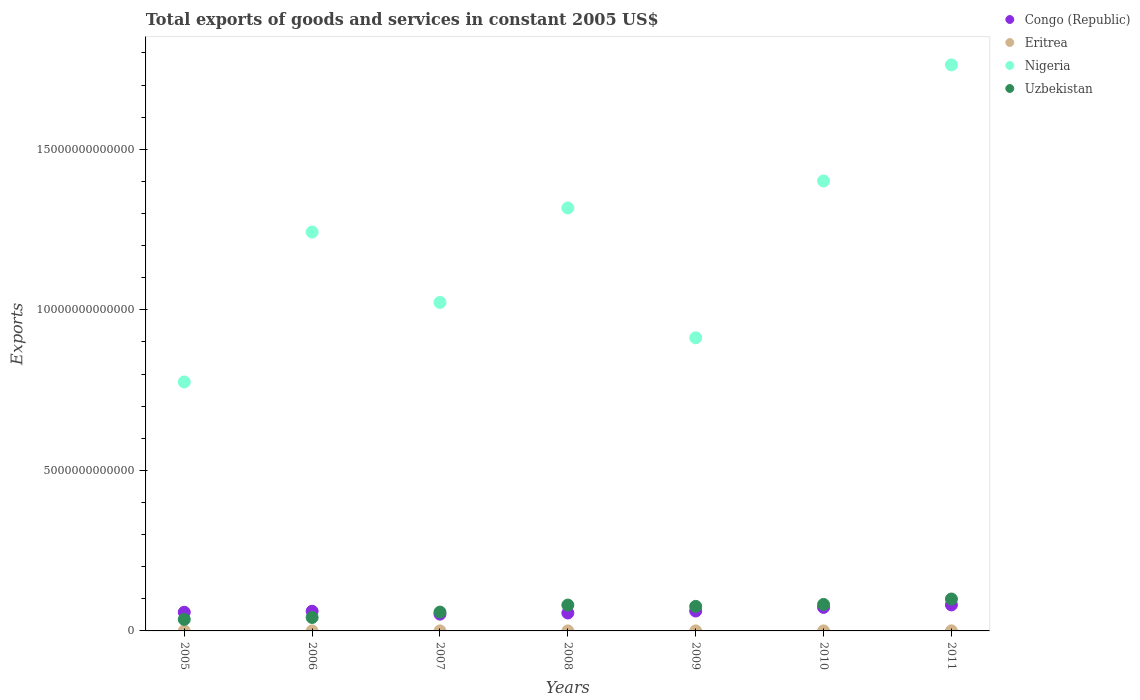How many different coloured dotlines are there?
Give a very brief answer. 4. Is the number of dotlines equal to the number of legend labels?
Provide a short and direct response. Yes. What is the total exports of goods and services in Eritrea in 2005?
Your answer should be compact. 6.78e+08. Across all years, what is the maximum total exports of goods and services in Eritrea?
Give a very brief answer. 2.84e+09. Across all years, what is the minimum total exports of goods and services in Eritrea?
Provide a short and direct response. 5.33e+08. In which year was the total exports of goods and services in Eritrea minimum?
Offer a very short reply. 2008. What is the total total exports of goods and services in Uzbekistan in the graph?
Keep it short and to the point. 4.75e+12. What is the difference between the total exports of goods and services in Congo (Republic) in 2010 and that in 2011?
Keep it short and to the point. -7.70e+1. What is the difference between the total exports of goods and services in Nigeria in 2011 and the total exports of goods and services in Congo (Republic) in 2007?
Offer a terse response. 1.71e+13. What is the average total exports of goods and services in Nigeria per year?
Keep it short and to the point. 1.20e+13. In the year 2006, what is the difference between the total exports of goods and services in Nigeria and total exports of goods and services in Uzbekistan?
Offer a terse response. 1.20e+13. What is the ratio of the total exports of goods and services in Congo (Republic) in 2005 to that in 2006?
Keep it short and to the point. 0.95. Is the total exports of goods and services in Nigeria in 2006 less than that in 2009?
Make the answer very short. No. What is the difference between the highest and the second highest total exports of goods and services in Congo (Republic)?
Provide a short and direct response. 7.70e+1. What is the difference between the highest and the lowest total exports of goods and services in Congo (Republic)?
Your answer should be compact. 2.87e+11. Is it the case that in every year, the sum of the total exports of goods and services in Nigeria and total exports of goods and services in Congo (Republic)  is greater than the sum of total exports of goods and services in Uzbekistan and total exports of goods and services in Eritrea?
Your response must be concise. Yes. Is it the case that in every year, the sum of the total exports of goods and services in Eritrea and total exports of goods and services in Congo (Republic)  is greater than the total exports of goods and services in Nigeria?
Offer a terse response. No. Does the total exports of goods and services in Eritrea monotonically increase over the years?
Keep it short and to the point. No. Is the total exports of goods and services in Uzbekistan strictly less than the total exports of goods and services in Eritrea over the years?
Provide a succinct answer. No. How many years are there in the graph?
Your response must be concise. 7. What is the difference between two consecutive major ticks on the Y-axis?
Offer a terse response. 5.00e+12. Does the graph contain any zero values?
Offer a very short reply. No. Does the graph contain grids?
Your answer should be very brief. No. How many legend labels are there?
Offer a very short reply. 4. How are the legend labels stacked?
Provide a short and direct response. Vertical. What is the title of the graph?
Give a very brief answer. Total exports of goods and services in constant 2005 US$. What is the label or title of the X-axis?
Your response must be concise. Years. What is the label or title of the Y-axis?
Offer a terse response. Exports. What is the Exports of Congo (Republic) in 2005?
Provide a short and direct response. 5.82e+11. What is the Exports of Eritrea in 2005?
Your answer should be compact. 6.78e+08. What is the Exports of Nigeria in 2005?
Provide a short and direct response. 7.75e+12. What is the Exports in Uzbekistan in 2005?
Keep it short and to the point. 3.59e+11. What is the Exports of Congo (Republic) in 2006?
Your response must be concise. 6.13e+11. What is the Exports of Eritrea in 2006?
Provide a short and direct response. 7.80e+08. What is the Exports in Nigeria in 2006?
Ensure brevity in your answer.  1.24e+13. What is the Exports of Uzbekistan in 2006?
Ensure brevity in your answer.  4.19e+11. What is the Exports of Congo (Republic) in 2007?
Offer a terse response. 5.22e+11. What is the Exports in Eritrea in 2007?
Your response must be concise. 6.78e+08. What is the Exports of Nigeria in 2007?
Provide a short and direct response. 1.02e+13. What is the Exports of Uzbekistan in 2007?
Provide a short and direct response. 5.86e+11. What is the Exports of Congo (Republic) in 2008?
Provide a succinct answer. 5.58e+11. What is the Exports of Eritrea in 2008?
Ensure brevity in your answer.  5.33e+08. What is the Exports of Nigeria in 2008?
Make the answer very short. 1.32e+13. What is the Exports of Uzbekistan in 2008?
Your answer should be very brief. 8.05e+11. What is the Exports in Congo (Republic) in 2009?
Your answer should be very brief. 6.20e+11. What is the Exports of Eritrea in 2009?
Your answer should be compact. 7.26e+08. What is the Exports of Nigeria in 2009?
Offer a very short reply. 9.13e+12. What is the Exports in Uzbekistan in 2009?
Offer a terse response. 7.64e+11. What is the Exports in Congo (Republic) in 2010?
Give a very brief answer. 7.33e+11. What is the Exports of Eritrea in 2010?
Provide a short and direct response. 8.53e+08. What is the Exports of Nigeria in 2010?
Ensure brevity in your answer.  1.40e+13. What is the Exports in Uzbekistan in 2010?
Your answer should be very brief. 8.25e+11. What is the Exports of Congo (Republic) in 2011?
Ensure brevity in your answer.  8.10e+11. What is the Exports in Eritrea in 2011?
Provide a succinct answer. 2.84e+09. What is the Exports of Nigeria in 2011?
Give a very brief answer. 1.76e+13. What is the Exports of Uzbekistan in 2011?
Provide a short and direct response. 9.94e+11. Across all years, what is the maximum Exports in Congo (Republic)?
Your answer should be compact. 8.10e+11. Across all years, what is the maximum Exports in Eritrea?
Offer a very short reply. 2.84e+09. Across all years, what is the maximum Exports of Nigeria?
Provide a succinct answer. 1.76e+13. Across all years, what is the maximum Exports in Uzbekistan?
Ensure brevity in your answer.  9.94e+11. Across all years, what is the minimum Exports of Congo (Republic)?
Keep it short and to the point. 5.22e+11. Across all years, what is the minimum Exports of Eritrea?
Your answer should be very brief. 5.33e+08. Across all years, what is the minimum Exports in Nigeria?
Your response must be concise. 7.75e+12. Across all years, what is the minimum Exports of Uzbekistan?
Provide a succinct answer. 3.59e+11. What is the total Exports of Congo (Republic) in the graph?
Provide a short and direct response. 4.44e+12. What is the total Exports of Eritrea in the graph?
Keep it short and to the point. 7.09e+09. What is the total Exports in Nigeria in the graph?
Your answer should be very brief. 8.43e+13. What is the total Exports of Uzbekistan in the graph?
Provide a short and direct response. 4.75e+12. What is the difference between the Exports in Congo (Republic) in 2005 and that in 2006?
Your answer should be compact. -3.14e+1. What is the difference between the Exports in Eritrea in 2005 and that in 2006?
Keep it short and to the point. -1.02e+08. What is the difference between the Exports of Nigeria in 2005 and that in 2006?
Your response must be concise. -4.67e+12. What is the difference between the Exports in Uzbekistan in 2005 and that in 2006?
Make the answer very short. -6.03e+1. What is the difference between the Exports in Congo (Republic) in 2005 and that in 2007?
Give a very brief answer. 5.97e+1. What is the difference between the Exports in Eritrea in 2005 and that in 2007?
Give a very brief answer. 9.37e+04. What is the difference between the Exports of Nigeria in 2005 and that in 2007?
Provide a succinct answer. -2.48e+12. What is the difference between the Exports in Uzbekistan in 2005 and that in 2007?
Offer a terse response. -2.28e+11. What is the difference between the Exports of Congo (Republic) in 2005 and that in 2008?
Your answer should be compact. 2.44e+1. What is the difference between the Exports of Eritrea in 2005 and that in 2008?
Your response must be concise. 1.45e+08. What is the difference between the Exports in Nigeria in 2005 and that in 2008?
Your answer should be compact. -5.42e+12. What is the difference between the Exports in Uzbekistan in 2005 and that in 2008?
Offer a very short reply. -4.47e+11. What is the difference between the Exports in Congo (Republic) in 2005 and that in 2009?
Make the answer very short. -3.79e+1. What is the difference between the Exports of Eritrea in 2005 and that in 2009?
Provide a succinct answer. -4.80e+07. What is the difference between the Exports in Nigeria in 2005 and that in 2009?
Your answer should be very brief. -1.37e+12. What is the difference between the Exports of Uzbekistan in 2005 and that in 2009?
Give a very brief answer. -4.05e+11. What is the difference between the Exports of Congo (Republic) in 2005 and that in 2010?
Your response must be concise. -1.51e+11. What is the difference between the Exports of Eritrea in 2005 and that in 2010?
Your answer should be very brief. -1.75e+08. What is the difference between the Exports in Nigeria in 2005 and that in 2010?
Ensure brevity in your answer.  -6.26e+12. What is the difference between the Exports of Uzbekistan in 2005 and that in 2010?
Offer a terse response. -4.66e+11. What is the difference between the Exports of Congo (Republic) in 2005 and that in 2011?
Ensure brevity in your answer.  -2.28e+11. What is the difference between the Exports of Eritrea in 2005 and that in 2011?
Offer a very short reply. -2.16e+09. What is the difference between the Exports in Nigeria in 2005 and that in 2011?
Ensure brevity in your answer.  -9.87e+12. What is the difference between the Exports in Uzbekistan in 2005 and that in 2011?
Offer a very short reply. -6.35e+11. What is the difference between the Exports in Congo (Republic) in 2006 and that in 2007?
Offer a terse response. 9.11e+1. What is the difference between the Exports in Eritrea in 2006 and that in 2007?
Make the answer very short. 1.02e+08. What is the difference between the Exports of Nigeria in 2006 and that in 2007?
Your response must be concise. 2.19e+12. What is the difference between the Exports of Uzbekistan in 2006 and that in 2007?
Provide a short and direct response. -1.67e+11. What is the difference between the Exports in Congo (Republic) in 2006 and that in 2008?
Give a very brief answer. 5.58e+1. What is the difference between the Exports of Eritrea in 2006 and that in 2008?
Keep it short and to the point. 2.47e+08. What is the difference between the Exports in Nigeria in 2006 and that in 2008?
Your answer should be compact. -7.50e+11. What is the difference between the Exports in Uzbekistan in 2006 and that in 2008?
Make the answer very short. -3.86e+11. What is the difference between the Exports of Congo (Republic) in 2006 and that in 2009?
Offer a very short reply. -6.50e+09. What is the difference between the Exports in Eritrea in 2006 and that in 2009?
Keep it short and to the point. 5.43e+07. What is the difference between the Exports in Nigeria in 2006 and that in 2009?
Give a very brief answer. 3.29e+12. What is the difference between the Exports in Uzbekistan in 2006 and that in 2009?
Provide a short and direct response. -3.45e+11. What is the difference between the Exports of Congo (Republic) in 2006 and that in 2010?
Offer a very short reply. -1.19e+11. What is the difference between the Exports of Eritrea in 2006 and that in 2010?
Your answer should be compact. -7.27e+07. What is the difference between the Exports of Nigeria in 2006 and that in 2010?
Provide a short and direct response. -1.59e+12. What is the difference between the Exports of Uzbekistan in 2006 and that in 2010?
Offer a terse response. -4.06e+11. What is the difference between the Exports of Congo (Republic) in 2006 and that in 2011?
Your response must be concise. -1.96e+11. What is the difference between the Exports in Eritrea in 2006 and that in 2011?
Make the answer very short. -2.06e+09. What is the difference between the Exports in Nigeria in 2006 and that in 2011?
Provide a succinct answer. -5.21e+12. What is the difference between the Exports of Uzbekistan in 2006 and that in 2011?
Provide a short and direct response. -5.75e+11. What is the difference between the Exports in Congo (Republic) in 2007 and that in 2008?
Offer a terse response. -3.53e+1. What is the difference between the Exports of Eritrea in 2007 and that in 2008?
Make the answer very short. 1.45e+08. What is the difference between the Exports of Nigeria in 2007 and that in 2008?
Keep it short and to the point. -2.94e+12. What is the difference between the Exports in Uzbekistan in 2007 and that in 2008?
Provide a succinct answer. -2.19e+11. What is the difference between the Exports of Congo (Republic) in 2007 and that in 2009?
Your answer should be very brief. -9.76e+1. What is the difference between the Exports in Eritrea in 2007 and that in 2009?
Offer a terse response. -4.81e+07. What is the difference between the Exports in Nigeria in 2007 and that in 2009?
Offer a terse response. 1.10e+12. What is the difference between the Exports in Uzbekistan in 2007 and that in 2009?
Your answer should be very brief. -1.78e+11. What is the difference between the Exports of Congo (Republic) in 2007 and that in 2010?
Offer a terse response. -2.10e+11. What is the difference between the Exports in Eritrea in 2007 and that in 2010?
Your answer should be compact. -1.75e+08. What is the difference between the Exports in Nigeria in 2007 and that in 2010?
Offer a terse response. -3.78e+12. What is the difference between the Exports in Uzbekistan in 2007 and that in 2010?
Provide a succinct answer. -2.39e+11. What is the difference between the Exports of Congo (Republic) in 2007 and that in 2011?
Keep it short and to the point. -2.87e+11. What is the difference between the Exports in Eritrea in 2007 and that in 2011?
Offer a very short reply. -2.16e+09. What is the difference between the Exports in Nigeria in 2007 and that in 2011?
Make the answer very short. -7.40e+12. What is the difference between the Exports in Uzbekistan in 2007 and that in 2011?
Your response must be concise. -4.07e+11. What is the difference between the Exports in Congo (Republic) in 2008 and that in 2009?
Give a very brief answer. -6.23e+1. What is the difference between the Exports in Eritrea in 2008 and that in 2009?
Ensure brevity in your answer.  -1.93e+08. What is the difference between the Exports in Nigeria in 2008 and that in 2009?
Your answer should be very brief. 4.04e+12. What is the difference between the Exports in Uzbekistan in 2008 and that in 2009?
Your answer should be very brief. 4.12e+1. What is the difference between the Exports in Congo (Republic) in 2008 and that in 2010?
Keep it short and to the point. -1.75e+11. What is the difference between the Exports of Eritrea in 2008 and that in 2010?
Provide a short and direct response. -3.20e+08. What is the difference between the Exports in Nigeria in 2008 and that in 2010?
Your answer should be compact. -8.42e+11. What is the difference between the Exports of Uzbekistan in 2008 and that in 2010?
Your response must be concise. -1.95e+1. What is the difference between the Exports in Congo (Republic) in 2008 and that in 2011?
Make the answer very short. -2.52e+11. What is the difference between the Exports in Eritrea in 2008 and that in 2011?
Provide a succinct answer. -2.31e+09. What is the difference between the Exports of Nigeria in 2008 and that in 2011?
Offer a very short reply. -4.46e+12. What is the difference between the Exports of Uzbekistan in 2008 and that in 2011?
Ensure brevity in your answer.  -1.88e+11. What is the difference between the Exports of Congo (Republic) in 2009 and that in 2010?
Offer a terse response. -1.13e+11. What is the difference between the Exports in Eritrea in 2009 and that in 2010?
Offer a very short reply. -1.27e+08. What is the difference between the Exports of Nigeria in 2009 and that in 2010?
Offer a terse response. -4.89e+12. What is the difference between the Exports of Uzbekistan in 2009 and that in 2010?
Provide a short and direct response. -6.07e+1. What is the difference between the Exports of Congo (Republic) in 2009 and that in 2011?
Your answer should be very brief. -1.90e+11. What is the difference between the Exports in Eritrea in 2009 and that in 2011?
Offer a terse response. -2.12e+09. What is the difference between the Exports of Nigeria in 2009 and that in 2011?
Ensure brevity in your answer.  -8.50e+12. What is the difference between the Exports of Uzbekistan in 2009 and that in 2011?
Make the answer very short. -2.29e+11. What is the difference between the Exports of Congo (Republic) in 2010 and that in 2011?
Give a very brief answer. -7.70e+1. What is the difference between the Exports of Eritrea in 2010 and that in 2011?
Offer a terse response. -1.99e+09. What is the difference between the Exports in Nigeria in 2010 and that in 2011?
Offer a terse response. -3.61e+12. What is the difference between the Exports of Uzbekistan in 2010 and that in 2011?
Keep it short and to the point. -1.69e+11. What is the difference between the Exports in Congo (Republic) in 2005 and the Exports in Eritrea in 2006?
Your answer should be very brief. 5.81e+11. What is the difference between the Exports in Congo (Republic) in 2005 and the Exports in Nigeria in 2006?
Provide a short and direct response. -1.18e+13. What is the difference between the Exports in Congo (Republic) in 2005 and the Exports in Uzbekistan in 2006?
Your response must be concise. 1.63e+11. What is the difference between the Exports in Eritrea in 2005 and the Exports in Nigeria in 2006?
Offer a very short reply. -1.24e+13. What is the difference between the Exports in Eritrea in 2005 and the Exports in Uzbekistan in 2006?
Offer a very short reply. -4.18e+11. What is the difference between the Exports of Nigeria in 2005 and the Exports of Uzbekistan in 2006?
Your response must be concise. 7.33e+12. What is the difference between the Exports in Congo (Republic) in 2005 and the Exports in Eritrea in 2007?
Provide a succinct answer. 5.81e+11. What is the difference between the Exports in Congo (Republic) in 2005 and the Exports in Nigeria in 2007?
Offer a very short reply. -9.65e+12. What is the difference between the Exports of Congo (Republic) in 2005 and the Exports of Uzbekistan in 2007?
Provide a succinct answer. -4.44e+09. What is the difference between the Exports of Eritrea in 2005 and the Exports of Nigeria in 2007?
Offer a terse response. -1.02e+13. What is the difference between the Exports of Eritrea in 2005 and the Exports of Uzbekistan in 2007?
Provide a succinct answer. -5.86e+11. What is the difference between the Exports in Nigeria in 2005 and the Exports in Uzbekistan in 2007?
Provide a short and direct response. 7.17e+12. What is the difference between the Exports in Congo (Republic) in 2005 and the Exports in Eritrea in 2008?
Provide a short and direct response. 5.81e+11. What is the difference between the Exports of Congo (Republic) in 2005 and the Exports of Nigeria in 2008?
Offer a terse response. -1.26e+13. What is the difference between the Exports in Congo (Republic) in 2005 and the Exports in Uzbekistan in 2008?
Give a very brief answer. -2.24e+11. What is the difference between the Exports of Eritrea in 2005 and the Exports of Nigeria in 2008?
Ensure brevity in your answer.  -1.32e+13. What is the difference between the Exports in Eritrea in 2005 and the Exports in Uzbekistan in 2008?
Give a very brief answer. -8.05e+11. What is the difference between the Exports in Nigeria in 2005 and the Exports in Uzbekistan in 2008?
Provide a succinct answer. 6.95e+12. What is the difference between the Exports of Congo (Republic) in 2005 and the Exports of Eritrea in 2009?
Keep it short and to the point. 5.81e+11. What is the difference between the Exports in Congo (Republic) in 2005 and the Exports in Nigeria in 2009?
Provide a succinct answer. -8.55e+12. What is the difference between the Exports in Congo (Republic) in 2005 and the Exports in Uzbekistan in 2009?
Your answer should be compact. -1.82e+11. What is the difference between the Exports in Eritrea in 2005 and the Exports in Nigeria in 2009?
Provide a short and direct response. -9.13e+12. What is the difference between the Exports of Eritrea in 2005 and the Exports of Uzbekistan in 2009?
Provide a succinct answer. -7.64e+11. What is the difference between the Exports in Nigeria in 2005 and the Exports in Uzbekistan in 2009?
Your response must be concise. 6.99e+12. What is the difference between the Exports of Congo (Republic) in 2005 and the Exports of Eritrea in 2010?
Provide a short and direct response. 5.81e+11. What is the difference between the Exports in Congo (Republic) in 2005 and the Exports in Nigeria in 2010?
Your answer should be very brief. -1.34e+13. What is the difference between the Exports in Congo (Republic) in 2005 and the Exports in Uzbekistan in 2010?
Ensure brevity in your answer.  -2.43e+11. What is the difference between the Exports of Eritrea in 2005 and the Exports of Nigeria in 2010?
Provide a succinct answer. -1.40e+13. What is the difference between the Exports of Eritrea in 2005 and the Exports of Uzbekistan in 2010?
Provide a short and direct response. -8.24e+11. What is the difference between the Exports of Nigeria in 2005 and the Exports of Uzbekistan in 2010?
Give a very brief answer. 6.93e+12. What is the difference between the Exports of Congo (Republic) in 2005 and the Exports of Eritrea in 2011?
Give a very brief answer. 5.79e+11. What is the difference between the Exports in Congo (Republic) in 2005 and the Exports in Nigeria in 2011?
Offer a terse response. -1.70e+13. What is the difference between the Exports of Congo (Republic) in 2005 and the Exports of Uzbekistan in 2011?
Provide a short and direct response. -4.12e+11. What is the difference between the Exports of Eritrea in 2005 and the Exports of Nigeria in 2011?
Give a very brief answer. -1.76e+13. What is the difference between the Exports in Eritrea in 2005 and the Exports in Uzbekistan in 2011?
Provide a succinct answer. -9.93e+11. What is the difference between the Exports of Nigeria in 2005 and the Exports of Uzbekistan in 2011?
Offer a terse response. 6.76e+12. What is the difference between the Exports in Congo (Republic) in 2006 and the Exports in Eritrea in 2007?
Offer a terse response. 6.13e+11. What is the difference between the Exports in Congo (Republic) in 2006 and the Exports in Nigeria in 2007?
Make the answer very short. -9.62e+12. What is the difference between the Exports in Congo (Republic) in 2006 and the Exports in Uzbekistan in 2007?
Your answer should be compact. 2.70e+1. What is the difference between the Exports in Eritrea in 2006 and the Exports in Nigeria in 2007?
Offer a very short reply. -1.02e+13. What is the difference between the Exports in Eritrea in 2006 and the Exports in Uzbekistan in 2007?
Your response must be concise. -5.86e+11. What is the difference between the Exports in Nigeria in 2006 and the Exports in Uzbekistan in 2007?
Ensure brevity in your answer.  1.18e+13. What is the difference between the Exports of Congo (Republic) in 2006 and the Exports of Eritrea in 2008?
Make the answer very short. 6.13e+11. What is the difference between the Exports in Congo (Republic) in 2006 and the Exports in Nigeria in 2008?
Your answer should be compact. -1.26e+13. What is the difference between the Exports in Congo (Republic) in 2006 and the Exports in Uzbekistan in 2008?
Your response must be concise. -1.92e+11. What is the difference between the Exports in Eritrea in 2006 and the Exports in Nigeria in 2008?
Offer a very short reply. -1.32e+13. What is the difference between the Exports in Eritrea in 2006 and the Exports in Uzbekistan in 2008?
Your answer should be very brief. -8.05e+11. What is the difference between the Exports in Nigeria in 2006 and the Exports in Uzbekistan in 2008?
Offer a very short reply. 1.16e+13. What is the difference between the Exports of Congo (Republic) in 2006 and the Exports of Eritrea in 2009?
Offer a terse response. 6.13e+11. What is the difference between the Exports in Congo (Republic) in 2006 and the Exports in Nigeria in 2009?
Keep it short and to the point. -8.51e+12. What is the difference between the Exports of Congo (Republic) in 2006 and the Exports of Uzbekistan in 2009?
Ensure brevity in your answer.  -1.51e+11. What is the difference between the Exports in Eritrea in 2006 and the Exports in Nigeria in 2009?
Give a very brief answer. -9.13e+12. What is the difference between the Exports in Eritrea in 2006 and the Exports in Uzbekistan in 2009?
Offer a terse response. -7.63e+11. What is the difference between the Exports of Nigeria in 2006 and the Exports of Uzbekistan in 2009?
Keep it short and to the point. 1.17e+13. What is the difference between the Exports of Congo (Republic) in 2006 and the Exports of Eritrea in 2010?
Offer a terse response. 6.12e+11. What is the difference between the Exports of Congo (Republic) in 2006 and the Exports of Nigeria in 2010?
Provide a short and direct response. -1.34e+13. What is the difference between the Exports in Congo (Republic) in 2006 and the Exports in Uzbekistan in 2010?
Make the answer very short. -2.12e+11. What is the difference between the Exports of Eritrea in 2006 and the Exports of Nigeria in 2010?
Ensure brevity in your answer.  -1.40e+13. What is the difference between the Exports of Eritrea in 2006 and the Exports of Uzbekistan in 2010?
Keep it short and to the point. -8.24e+11. What is the difference between the Exports of Nigeria in 2006 and the Exports of Uzbekistan in 2010?
Give a very brief answer. 1.16e+13. What is the difference between the Exports in Congo (Republic) in 2006 and the Exports in Eritrea in 2011?
Your answer should be very brief. 6.11e+11. What is the difference between the Exports of Congo (Republic) in 2006 and the Exports of Nigeria in 2011?
Offer a very short reply. -1.70e+13. What is the difference between the Exports of Congo (Republic) in 2006 and the Exports of Uzbekistan in 2011?
Your answer should be compact. -3.80e+11. What is the difference between the Exports in Eritrea in 2006 and the Exports in Nigeria in 2011?
Provide a succinct answer. -1.76e+13. What is the difference between the Exports of Eritrea in 2006 and the Exports of Uzbekistan in 2011?
Make the answer very short. -9.93e+11. What is the difference between the Exports in Nigeria in 2006 and the Exports in Uzbekistan in 2011?
Offer a very short reply. 1.14e+13. What is the difference between the Exports of Congo (Republic) in 2007 and the Exports of Eritrea in 2008?
Make the answer very short. 5.22e+11. What is the difference between the Exports of Congo (Republic) in 2007 and the Exports of Nigeria in 2008?
Your answer should be compact. -1.27e+13. What is the difference between the Exports of Congo (Republic) in 2007 and the Exports of Uzbekistan in 2008?
Your answer should be very brief. -2.83e+11. What is the difference between the Exports of Eritrea in 2007 and the Exports of Nigeria in 2008?
Your answer should be very brief. -1.32e+13. What is the difference between the Exports in Eritrea in 2007 and the Exports in Uzbekistan in 2008?
Provide a short and direct response. -8.05e+11. What is the difference between the Exports of Nigeria in 2007 and the Exports of Uzbekistan in 2008?
Provide a succinct answer. 9.42e+12. What is the difference between the Exports of Congo (Republic) in 2007 and the Exports of Eritrea in 2009?
Provide a succinct answer. 5.22e+11. What is the difference between the Exports of Congo (Republic) in 2007 and the Exports of Nigeria in 2009?
Provide a succinct answer. -8.61e+12. What is the difference between the Exports in Congo (Republic) in 2007 and the Exports in Uzbekistan in 2009?
Provide a succinct answer. -2.42e+11. What is the difference between the Exports of Eritrea in 2007 and the Exports of Nigeria in 2009?
Give a very brief answer. -9.13e+12. What is the difference between the Exports of Eritrea in 2007 and the Exports of Uzbekistan in 2009?
Offer a terse response. -7.64e+11. What is the difference between the Exports of Nigeria in 2007 and the Exports of Uzbekistan in 2009?
Your answer should be very brief. 9.47e+12. What is the difference between the Exports of Congo (Republic) in 2007 and the Exports of Eritrea in 2010?
Your response must be concise. 5.21e+11. What is the difference between the Exports of Congo (Republic) in 2007 and the Exports of Nigeria in 2010?
Give a very brief answer. -1.35e+13. What is the difference between the Exports of Congo (Republic) in 2007 and the Exports of Uzbekistan in 2010?
Your answer should be very brief. -3.03e+11. What is the difference between the Exports of Eritrea in 2007 and the Exports of Nigeria in 2010?
Your response must be concise. -1.40e+13. What is the difference between the Exports in Eritrea in 2007 and the Exports in Uzbekistan in 2010?
Provide a succinct answer. -8.24e+11. What is the difference between the Exports in Nigeria in 2007 and the Exports in Uzbekistan in 2010?
Ensure brevity in your answer.  9.40e+12. What is the difference between the Exports of Congo (Republic) in 2007 and the Exports of Eritrea in 2011?
Ensure brevity in your answer.  5.19e+11. What is the difference between the Exports of Congo (Republic) in 2007 and the Exports of Nigeria in 2011?
Provide a succinct answer. -1.71e+13. What is the difference between the Exports in Congo (Republic) in 2007 and the Exports in Uzbekistan in 2011?
Your response must be concise. -4.71e+11. What is the difference between the Exports in Eritrea in 2007 and the Exports in Nigeria in 2011?
Your response must be concise. -1.76e+13. What is the difference between the Exports of Eritrea in 2007 and the Exports of Uzbekistan in 2011?
Ensure brevity in your answer.  -9.93e+11. What is the difference between the Exports of Nigeria in 2007 and the Exports of Uzbekistan in 2011?
Provide a succinct answer. 9.24e+12. What is the difference between the Exports of Congo (Republic) in 2008 and the Exports of Eritrea in 2009?
Give a very brief answer. 5.57e+11. What is the difference between the Exports in Congo (Republic) in 2008 and the Exports in Nigeria in 2009?
Make the answer very short. -8.57e+12. What is the difference between the Exports in Congo (Republic) in 2008 and the Exports in Uzbekistan in 2009?
Provide a short and direct response. -2.07e+11. What is the difference between the Exports of Eritrea in 2008 and the Exports of Nigeria in 2009?
Your answer should be very brief. -9.13e+12. What is the difference between the Exports of Eritrea in 2008 and the Exports of Uzbekistan in 2009?
Provide a short and direct response. -7.64e+11. What is the difference between the Exports in Nigeria in 2008 and the Exports in Uzbekistan in 2009?
Give a very brief answer. 1.24e+13. What is the difference between the Exports of Congo (Republic) in 2008 and the Exports of Eritrea in 2010?
Provide a short and direct response. 5.57e+11. What is the difference between the Exports of Congo (Republic) in 2008 and the Exports of Nigeria in 2010?
Your answer should be compact. -1.35e+13. What is the difference between the Exports in Congo (Republic) in 2008 and the Exports in Uzbekistan in 2010?
Your answer should be very brief. -2.67e+11. What is the difference between the Exports of Eritrea in 2008 and the Exports of Nigeria in 2010?
Provide a succinct answer. -1.40e+13. What is the difference between the Exports of Eritrea in 2008 and the Exports of Uzbekistan in 2010?
Your response must be concise. -8.24e+11. What is the difference between the Exports in Nigeria in 2008 and the Exports in Uzbekistan in 2010?
Provide a short and direct response. 1.23e+13. What is the difference between the Exports in Congo (Republic) in 2008 and the Exports in Eritrea in 2011?
Give a very brief answer. 5.55e+11. What is the difference between the Exports in Congo (Republic) in 2008 and the Exports in Nigeria in 2011?
Give a very brief answer. -1.71e+13. What is the difference between the Exports of Congo (Republic) in 2008 and the Exports of Uzbekistan in 2011?
Your answer should be very brief. -4.36e+11. What is the difference between the Exports in Eritrea in 2008 and the Exports in Nigeria in 2011?
Ensure brevity in your answer.  -1.76e+13. What is the difference between the Exports of Eritrea in 2008 and the Exports of Uzbekistan in 2011?
Provide a short and direct response. -9.93e+11. What is the difference between the Exports of Nigeria in 2008 and the Exports of Uzbekistan in 2011?
Offer a very short reply. 1.22e+13. What is the difference between the Exports in Congo (Republic) in 2009 and the Exports in Eritrea in 2010?
Your answer should be compact. 6.19e+11. What is the difference between the Exports in Congo (Republic) in 2009 and the Exports in Nigeria in 2010?
Offer a terse response. -1.34e+13. What is the difference between the Exports in Congo (Republic) in 2009 and the Exports in Uzbekistan in 2010?
Your answer should be very brief. -2.05e+11. What is the difference between the Exports in Eritrea in 2009 and the Exports in Nigeria in 2010?
Keep it short and to the point. -1.40e+13. What is the difference between the Exports of Eritrea in 2009 and the Exports of Uzbekistan in 2010?
Offer a very short reply. -8.24e+11. What is the difference between the Exports of Nigeria in 2009 and the Exports of Uzbekistan in 2010?
Offer a terse response. 8.30e+12. What is the difference between the Exports of Congo (Republic) in 2009 and the Exports of Eritrea in 2011?
Give a very brief answer. 6.17e+11. What is the difference between the Exports of Congo (Republic) in 2009 and the Exports of Nigeria in 2011?
Ensure brevity in your answer.  -1.70e+13. What is the difference between the Exports of Congo (Republic) in 2009 and the Exports of Uzbekistan in 2011?
Keep it short and to the point. -3.74e+11. What is the difference between the Exports of Eritrea in 2009 and the Exports of Nigeria in 2011?
Provide a succinct answer. -1.76e+13. What is the difference between the Exports in Eritrea in 2009 and the Exports in Uzbekistan in 2011?
Ensure brevity in your answer.  -9.93e+11. What is the difference between the Exports in Nigeria in 2009 and the Exports in Uzbekistan in 2011?
Your answer should be compact. 8.13e+12. What is the difference between the Exports of Congo (Republic) in 2010 and the Exports of Eritrea in 2011?
Make the answer very short. 7.30e+11. What is the difference between the Exports in Congo (Republic) in 2010 and the Exports in Nigeria in 2011?
Your answer should be very brief. -1.69e+13. What is the difference between the Exports of Congo (Republic) in 2010 and the Exports of Uzbekistan in 2011?
Ensure brevity in your answer.  -2.61e+11. What is the difference between the Exports of Eritrea in 2010 and the Exports of Nigeria in 2011?
Give a very brief answer. -1.76e+13. What is the difference between the Exports of Eritrea in 2010 and the Exports of Uzbekistan in 2011?
Your answer should be very brief. -9.93e+11. What is the difference between the Exports in Nigeria in 2010 and the Exports in Uzbekistan in 2011?
Offer a terse response. 1.30e+13. What is the average Exports in Congo (Republic) per year?
Your answer should be compact. 6.34e+11. What is the average Exports in Eritrea per year?
Your response must be concise. 1.01e+09. What is the average Exports of Nigeria per year?
Your answer should be compact. 1.20e+13. What is the average Exports in Uzbekistan per year?
Offer a very short reply. 6.79e+11. In the year 2005, what is the difference between the Exports of Congo (Republic) and Exports of Eritrea?
Your answer should be very brief. 5.81e+11. In the year 2005, what is the difference between the Exports of Congo (Republic) and Exports of Nigeria?
Provide a short and direct response. -7.17e+12. In the year 2005, what is the difference between the Exports in Congo (Republic) and Exports in Uzbekistan?
Make the answer very short. 2.23e+11. In the year 2005, what is the difference between the Exports in Eritrea and Exports in Nigeria?
Provide a short and direct response. -7.75e+12. In the year 2005, what is the difference between the Exports in Eritrea and Exports in Uzbekistan?
Make the answer very short. -3.58e+11. In the year 2005, what is the difference between the Exports of Nigeria and Exports of Uzbekistan?
Make the answer very short. 7.39e+12. In the year 2006, what is the difference between the Exports in Congo (Republic) and Exports in Eritrea?
Offer a terse response. 6.13e+11. In the year 2006, what is the difference between the Exports in Congo (Republic) and Exports in Nigeria?
Provide a short and direct response. -1.18e+13. In the year 2006, what is the difference between the Exports of Congo (Republic) and Exports of Uzbekistan?
Your answer should be compact. 1.94e+11. In the year 2006, what is the difference between the Exports in Eritrea and Exports in Nigeria?
Provide a short and direct response. -1.24e+13. In the year 2006, what is the difference between the Exports of Eritrea and Exports of Uzbekistan?
Offer a very short reply. -4.18e+11. In the year 2006, what is the difference between the Exports in Nigeria and Exports in Uzbekistan?
Make the answer very short. 1.20e+13. In the year 2007, what is the difference between the Exports in Congo (Republic) and Exports in Eritrea?
Make the answer very short. 5.22e+11. In the year 2007, what is the difference between the Exports of Congo (Republic) and Exports of Nigeria?
Give a very brief answer. -9.71e+12. In the year 2007, what is the difference between the Exports in Congo (Republic) and Exports in Uzbekistan?
Ensure brevity in your answer.  -6.41e+1. In the year 2007, what is the difference between the Exports in Eritrea and Exports in Nigeria?
Make the answer very short. -1.02e+13. In the year 2007, what is the difference between the Exports of Eritrea and Exports of Uzbekistan?
Your answer should be very brief. -5.86e+11. In the year 2007, what is the difference between the Exports in Nigeria and Exports in Uzbekistan?
Keep it short and to the point. 9.64e+12. In the year 2008, what is the difference between the Exports of Congo (Republic) and Exports of Eritrea?
Offer a very short reply. 5.57e+11. In the year 2008, what is the difference between the Exports of Congo (Republic) and Exports of Nigeria?
Give a very brief answer. -1.26e+13. In the year 2008, what is the difference between the Exports of Congo (Republic) and Exports of Uzbekistan?
Your answer should be very brief. -2.48e+11. In the year 2008, what is the difference between the Exports of Eritrea and Exports of Nigeria?
Ensure brevity in your answer.  -1.32e+13. In the year 2008, what is the difference between the Exports in Eritrea and Exports in Uzbekistan?
Give a very brief answer. -8.05e+11. In the year 2008, what is the difference between the Exports of Nigeria and Exports of Uzbekistan?
Provide a succinct answer. 1.24e+13. In the year 2009, what is the difference between the Exports of Congo (Republic) and Exports of Eritrea?
Provide a short and direct response. 6.19e+11. In the year 2009, what is the difference between the Exports in Congo (Republic) and Exports in Nigeria?
Make the answer very short. -8.51e+12. In the year 2009, what is the difference between the Exports of Congo (Republic) and Exports of Uzbekistan?
Your answer should be compact. -1.44e+11. In the year 2009, what is the difference between the Exports in Eritrea and Exports in Nigeria?
Your response must be concise. -9.13e+12. In the year 2009, what is the difference between the Exports in Eritrea and Exports in Uzbekistan?
Give a very brief answer. -7.64e+11. In the year 2009, what is the difference between the Exports in Nigeria and Exports in Uzbekistan?
Your answer should be very brief. 8.36e+12. In the year 2010, what is the difference between the Exports in Congo (Republic) and Exports in Eritrea?
Offer a terse response. 7.32e+11. In the year 2010, what is the difference between the Exports of Congo (Republic) and Exports of Nigeria?
Make the answer very short. -1.33e+13. In the year 2010, what is the difference between the Exports in Congo (Republic) and Exports in Uzbekistan?
Offer a very short reply. -9.25e+1. In the year 2010, what is the difference between the Exports in Eritrea and Exports in Nigeria?
Give a very brief answer. -1.40e+13. In the year 2010, what is the difference between the Exports in Eritrea and Exports in Uzbekistan?
Your answer should be very brief. -8.24e+11. In the year 2010, what is the difference between the Exports of Nigeria and Exports of Uzbekistan?
Your response must be concise. 1.32e+13. In the year 2011, what is the difference between the Exports in Congo (Republic) and Exports in Eritrea?
Your answer should be compact. 8.07e+11. In the year 2011, what is the difference between the Exports in Congo (Republic) and Exports in Nigeria?
Your answer should be compact. -1.68e+13. In the year 2011, what is the difference between the Exports in Congo (Republic) and Exports in Uzbekistan?
Your response must be concise. -1.84e+11. In the year 2011, what is the difference between the Exports in Eritrea and Exports in Nigeria?
Your answer should be very brief. -1.76e+13. In the year 2011, what is the difference between the Exports of Eritrea and Exports of Uzbekistan?
Your answer should be compact. -9.91e+11. In the year 2011, what is the difference between the Exports of Nigeria and Exports of Uzbekistan?
Offer a very short reply. 1.66e+13. What is the ratio of the Exports of Congo (Republic) in 2005 to that in 2006?
Make the answer very short. 0.95. What is the ratio of the Exports in Eritrea in 2005 to that in 2006?
Your answer should be very brief. 0.87. What is the ratio of the Exports in Nigeria in 2005 to that in 2006?
Offer a very short reply. 0.62. What is the ratio of the Exports of Uzbekistan in 2005 to that in 2006?
Your response must be concise. 0.86. What is the ratio of the Exports in Congo (Republic) in 2005 to that in 2007?
Provide a succinct answer. 1.11. What is the ratio of the Exports of Nigeria in 2005 to that in 2007?
Keep it short and to the point. 0.76. What is the ratio of the Exports of Uzbekistan in 2005 to that in 2007?
Your answer should be very brief. 0.61. What is the ratio of the Exports in Congo (Republic) in 2005 to that in 2008?
Your answer should be compact. 1.04. What is the ratio of the Exports of Eritrea in 2005 to that in 2008?
Your response must be concise. 1.27. What is the ratio of the Exports in Nigeria in 2005 to that in 2008?
Give a very brief answer. 0.59. What is the ratio of the Exports in Uzbekistan in 2005 to that in 2008?
Your answer should be compact. 0.45. What is the ratio of the Exports in Congo (Republic) in 2005 to that in 2009?
Provide a succinct answer. 0.94. What is the ratio of the Exports of Eritrea in 2005 to that in 2009?
Make the answer very short. 0.93. What is the ratio of the Exports of Nigeria in 2005 to that in 2009?
Give a very brief answer. 0.85. What is the ratio of the Exports in Uzbekistan in 2005 to that in 2009?
Make the answer very short. 0.47. What is the ratio of the Exports of Congo (Republic) in 2005 to that in 2010?
Offer a terse response. 0.79. What is the ratio of the Exports in Eritrea in 2005 to that in 2010?
Your response must be concise. 0.79. What is the ratio of the Exports of Nigeria in 2005 to that in 2010?
Offer a very short reply. 0.55. What is the ratio of the Exports of Uzbekistan in 2005 to that in 2010?
Provide a succinct answer. 0.43. What is the ratio of the Exports in Congo (Republic) in 2005 to that in 2011?
Make the answer very short. 0.72. What is the ratio of the Exports in Eritrea in 2005 to that in 2011?
Make the answer very short. 0.24. What is the ratio of the Exports of Nigeria in 2005 to that in 2011?
Make the answer very short. 0.44. What is the ratio of the Exports of Uzbekistan in 2005 to that in 2011?
Give a very brief answer. 0.36. What is the ratio of the Exports of Congo (Republic) in 2006 to that in 2007?
Your answer should be compact. 1.17. What is the ratio of the Exports of Eritrea in 2006 to that in 2007?
Give a very brief answer. 1.15. What is the ratio of the Exports in Nigeria in 2006 to that in 2007?
Keep it short and to the point. 1.21. What is the ratio of the Exports in Uzbekistan in 2006 to that in 2007?
Provide a short and direct response. 0.71. What is the ratio of the Exports in Eritrea in 2006 to that in 2008?
Your answer should be very brief. 1.46. What is the ratio of the Exports of Nigeria in 2006 to that in 2008?
Offer a terse response. 0.94. What is the ratio of the Exports of Uzbekistan in 2006 to that in 2008?
Offer a terse response. 0.52. What is the ratio of the Exports in Eritrea in 2006 to that in 2009?
Your answer should be very brief. 1.07. What is the ratio of the Exports in Nigeria in 2006 to that in 2009?
Provide a succinct answer. 1.36. What is the ratio of the Exports in Uzbekistan in 2006 to that in 2009?
Ensure brevity in your answer.  0.55. What is the ratio of the Exports in Congo (Republic) in 2006 to that in 2010?
Make the answer very short. 0.84. What is the ratio of the Exports of Eritrea in 2006 to that in 2010?
Give a very brief answer. 0.91. What is the ratio of the Exports of Nigeria in 2006 to that in 2010?
Offer a very short reply. 0.89. What is the ratio of the Exports of Uzbekistan in 2006 to that in 2010?
Your response must be concise. 0.51. What is the ratio of the Exports of Congo (Republic) in 2006 to that in 2011?
Offer a very short reply. 0.76. What is the ratio of the Exports of Eritrea in 2006 to that in 2011?
Give a very brief answer. 0.27. What is the ratio of the Exports in Nigeria in 2006 to that in 2011?
Your answer should be very brief. 0.7. What is the ratio of the Exports of Uzbekistan in 2006 to that in 2011?
Give a very brief answer. 0.42. What is the ratio of the Exports in Congo (Republic) in 2007 to that in 2008?
Your answer should be compact. 0.94. What is the ratio of the Exports in Eritrea in 2007 to that in 2008?
Offer a terse response. 1.27. What is the ratio of the Exports in Nigeria in 2007 to that in 2008?
Your answer should be compact. 0.78. What is the ratio of the Exports of Uzbekistan in 2007 to that in 2008?
Your answer should be very brief. 0.73. What is the ratio of the Exports in Congo (Republic) in 2007 to that in 2009?
Offer a very short reply. 0.84. What is the ratio of the Exports in Eritrea in 2007 to that in 2009?
Make the answer very short. 0.93. What is the ratio of the Exports in Nigeria in 2007 to that in 2009?
Make the answer very short. 1.12. What is the ratio of the Exports in Uzbekistan in 2007 to that in 2009?
Ensure brevity in your answer.  0.77. What is the ratio of the Exports in Congo (Republic) in 2007 to that in 2010?
Keep it short and to the point. 0.71. What is the ratio of the Exports in Eritrea in 2007 to that in 2010?
Provide a short and direct response. 0.79. What is the ratio of the Exports of Nigeria in 2007 to that in 2010?
Give a very brief answer. 0.73. What is the ratio of the Exports in Uzbekistan in 2007 to that in 2010?
Make the answer very short. 0.71. What is the ratio of the Exports of Congo (Republic) in 2007 to that in 2011?
Keep it short and to the point. 0.65. What is the ratio of the Exports in Eritrea in 2007 to that in 2011?
Keep it short and to the point. 0.24. What is the ratio of the Exports in Nigeria in 2007 to that in 2011?
Ensure brevity in your answer.  0.58. What is the ratio of the Exports in Uzbekistan in 2007 to that in 2011?
Keep it short and to the point. 0.59. What is the ratio of the Exports of Congo (Republic) in 2008 to that in 2009?
Give a very brief answer. 0.9. What is the ratio of the Exports in Eritrea in 2008 to that in 2009?
Give a very brief answer. 0.73. What is the ratio of the Exports in Nigeria in 2008 to that in 2009?
Ensure brevity in your answer.  1.44. What is the ratio of the Exports in Uzbekistan in 2008 to that in 2009?
Provide a short and direct response. 1.05. What is the ratio of the Exports of Congo (Republic) in 2008 to that in 2010?
Your answer should be very brief. 0.76. What is the ratio of the Exports in Eritrea in 2008 to that in 2010?
Provide a succinct answer. 0.62. What is the ratio of the Exports of Nigeria in 2008 to that in 2010?
Offer a terse response. 0.94. What is the ratio of the Exports in Uzbekistan in 2008 to that in 2010?
Provide a succinct answer. 0.98. What is the ratio of the Exports in Congo (Republic) in 2008 to that in 2011?
Make the answer very short. 0.69. What is the ratio of the Exports in Eritrea in 2008 to that in 2011?
Provide a succinct answer. 0.19. What is the ratio of the Exports of Nigeria in 2008 to that in 2011?
Give a very brief answer. 0.75. What is the ratio of the Exports of Uzbekistan in 2008 to that in 2011?
Your response must be concise. 0.81. What is the ratio of the Exports of Congo (Republic) in 2009 to that in 2010?
Give a very brief answer. 0.85. What is the ratio of the Exports in Eritrea in 2009 to that in 2010?
Give a very brief answer. 0.85. What is the ratio of the Exports of Nigeria in 2009 to that in 2010?
Your response must be concise. 0.65. What is the ratio of the Exports in Uzbekistan in 2009 to that in 2010?
Your answer should be very brief. 0.93. What is the ratio of the Exports of Congo (Republic) in 2009 to that in 2011?
Keep it short and to the point. 0.77. What is the ratio of the Exports in Eritrea in 2009 to that in 2011?
Your answer should be very brief. 0.26. What is the ratio of the Exports of Nigeria in 2009 to that in 2011?
Keep it short and to the point. 0.52. What is the ratio of the Exports in Uzbekistan in 2009 to that in 2011?
Provide a succinct answer. 0.77. What is the ratio of the Exports in Congo (Republic) in 2010 to that in 2011?
Ensure brevity in your answer.  0.9. What is the ratio of the Exports of Eritrea in 2010 to that in 2011?
Offer a terse response. 0.3. What is the ratio of the Exports in Nigeria in 2010 to that in 2011?
Offer a very short reply. 0.8. What is the ratio of the Exports of Uzbekistan in 2010 to that in 2011?
Your answer should be compact. 0.83. What is the difference between the highest and the second highest Exports in Congo (Republic)?
Provide a short and direct response. 7.70e+1. What is the difference between the highest and the second highest Exports in Eritrea?
Provide a succinct answer. 1.99e+09. What is the difference between the highest and the second highest Exports of Nigeria?
Keep it short and to the point. 3.61e+12. What is the difference between the highest and the second highest Exports in Uzbekistan?
Your response must be concise. 1.69e+11. What is the difference between the highest and the lowest Exports in Congo (Republic)?
Your response must be concise. 2.87e+11. What is the difference between the highest and the lowest Exports in Eritrea?
Your answer should be compact. 2.31e+09. What is the difference between the highest and the lowest Exports of Nigeria?
Provide a succinct answer. 9.87e+12. What is the difference between the highest and the lowest Exports in Uzbekistan?
Keep it short and to the point. 6.35e+11. 